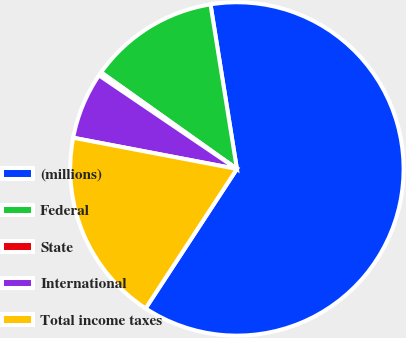Convert chart to OTSL. <chart><loc_0><loc_0><loc_500><loc_500><pie_chart><fcel>(millions)<fcel>Federal<fcel>State<fcel>International<fcel>Total income taxes<nl><fcel>61.76%<fcel>12.63%<fcel>0.35%<fcel>6.49%<fcel>18.77%<nl></chart> 